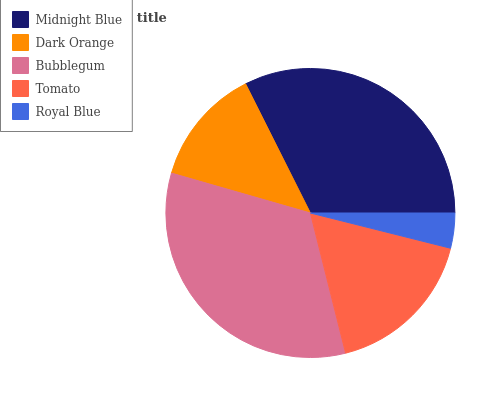Is Royal Blue the minimum?
Answer yes or no. Yes. Is Bubblegum the maximum?
Answer yes or no. Yes. Is Dark Orange the minimum?
Answer yes or no. No. Is Dark Orange the maximum?
Answer yes or no. No. Is Midnight Blue greater than Dark Orange?
Answer yes or no. Yes. Is Dark Orange less than Midnight Blue?
Answer yes or no. Yes. Is Dark Orange greater than Midnight Blue?
Answer yes or no. No. Is Midnight Blue less than Dark Orange?
Answer yes or no. No. Is Tomato the high median?
Answer yes or no. Yes. Is Tomato the low median?
Answer yes or no. Yes. Is Midnight Blue the high median?
Answer yes or no. No. Is Midnight Blue the low median?
Answer yes or no. No. 